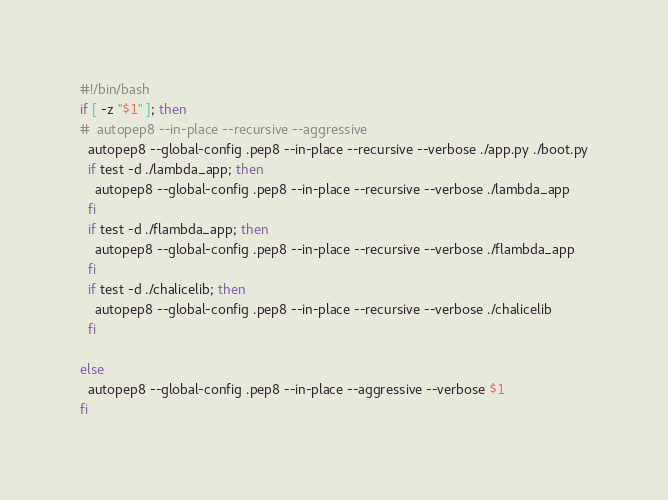<code> <loc_0><loc_0><loc_500><loc_500><_Bash_>#!/bin/bash
if [ -z "$1" ]; then
#  autopep8 --in-place --recursive --aggressive
  autopep8 --global-config .pep8 --in-place --recursive --verbose ./app.py ./boot.py
  if test -d ./lambda_app; then
    autopep8 --global-config .pep8 --in-place --recursive --verbose ./lambda_app
  fi
  if test -d ./flambda_app; then
    autopep8 --global-config .pep8 --in-place --recursive --verbose ./flambda_app
  fi
  if test -d ./chalicelib; then
    autopep8 --global-config .pep8 --in-place --recursive --verbose ./chalicelib
  fi

else
  autopep8 --global-config .pep8 --in-place --aggressive --verbose $1
fi
</code> 